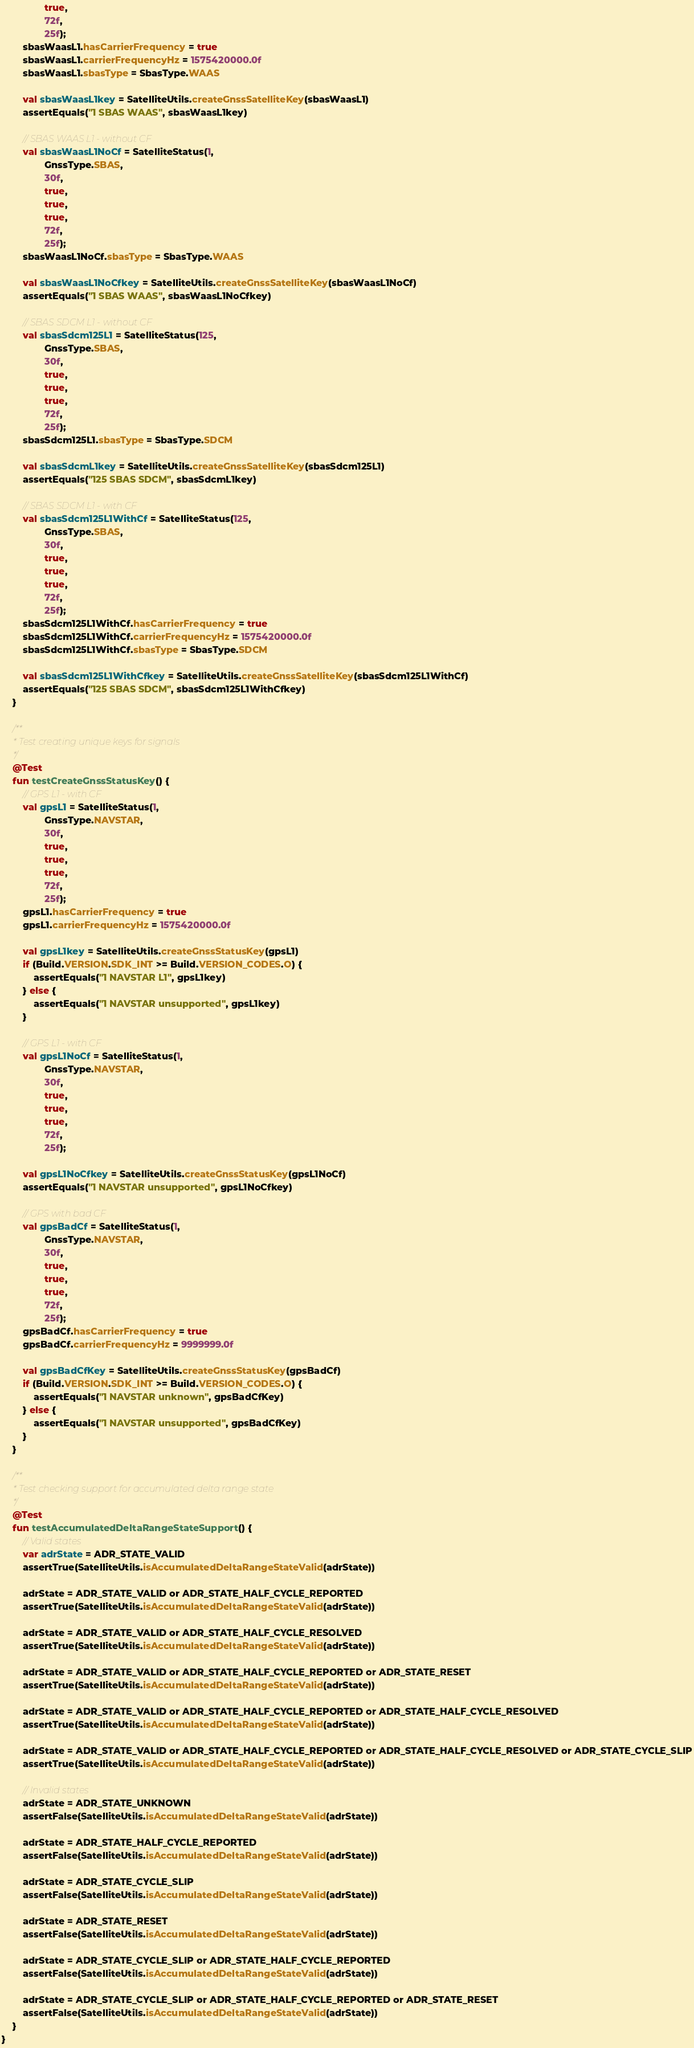<code> <loc_0><loc_0><loc_500><loc_500><_Kotlin_>                true,
                72f,
                25f);
        sbasWaasL1.hasCarrierFrequency = true
        sbasWaasL1.carrierFrequencyHz = 1575420000.0f
        sbasWaasL1.sbasType = SbasType.WAAS

        val sbasWaasL1key = SatelliteUtils.createGnssSatelliteKey(sbasWaasL1)
        assertEquals("1 SBAS WAAS", sbasWaasL1key)

        // SBAS WAAS L1 - without CF
        val sbasWaasL1NoCf = SatelliteStatus(1,
                GnssType.SBAS,
                30f,
                true,
                true,
                true,
                72f,
                25f);
        sbasWaasL1NoCf.sbasType = SbasType.WAAS

        val sbasWaasL1NoCfkey = SatelliteUtils.createGnssSatelliteKey(sbasWaasL1NoCf)
        assertEquals("1 SBAS WAAS", sbasWaasL1NoCfkey)

        // SBAS SDCM L1 - without CF
        val sbasSdcm125L1 = SatelliteStatus(125,
                GnssType.SBAS,
                30f,
                true,
                true,
                true,
                72f,
                25f);
        sbasSdcm125L1.sbasType = SbasType.SDCM

        val sbasSdcmL1key = SatelliteUtils.createGnssSatelliteKey(sbasSdcm125L1)
        assertEquals("125 SBAS SDCM", sbasSdcmL1key)

        // SBAS SDCM L1 - with CF
        val sbasSdcm125L1WithCf = SatelliteStatus(125,
                GnssType.SBAS,
                30f,
                true,
                true,
                true,
                72f,
                25f);
        sbasSdcm125L1WithCf.hasCarrierFrequency = true
        sbasSdcm125L1WithCf.carrierFrequencyHz = 1575420000.0f
        sbasSdcm125L1WithCf.sbasType = SbasType.SDCM

        val sbasSdcm125L1WithCfkey = SatelliteUtils.createGnssSatelliteKey(sbasSdcm125L1WithCf)
        assertEquals("125 SBAS SDCM", sbasSdcm125L1WithCfkey)
    }

    /**
     * Test creating unique keys for signals
     */
    @Test
    fun testCreateGnssStatusKey() {
        // GPS L1 - with CF
        val gpsL1 = SatelliteStatus(1,
                GnssType.NAVSTAR,
                30f,
                true,
                true,
                true,
                72f,
                25f);
        gpsL1.hasCarrierFrequency = true
        gpsL1.carrierFrequencyHz = 1575420000.0f

        val gpsL1key = SatelliteUtils.createGnssStatusKey(gpsL1)
        if (Build.VERSION.SDK_INT >= Build.VERSION_CODES.O) {
            assertEquals("1 NAVSTAR L1", gpsL1key)
        } else {
            assertEquals("1 NAVSTAR unsupported", gpsL1key)
        }

        // GPS L1 - with CF
        val gpsL1NoCf = SatelliteStatus(1,
                GnssType.NAVSTAR,
                30f,
                true,
                true,
                true,
                72f,
                25f);

        val gpsL1NoCfkey = SatelliteUtils.createGnssStatusKey(gpsL1NoCf)
        assertEquals("1 NAVSTAR unsupported", gpsL1NoCfkey)

        // GPS with bad CF
        val gpsBadCf = SatelliteStatus(1,
                GnssType.NAVSTAR,
                30f,
                true,
                true,
                true,
                72f,
                25f);
        gpsBadCf.hasCarrierFrequency = true
        gpsBadCf.carrierFrequencyHz = 9999999.0f

        val gpsBadCfKey = SatelliteUtils.createGnssStatusKey(gpsBadCf)
        if (Build.VERSION.SDK_INT >= Build.VERSION_CODES.O) {
            assertEquals("1 NAVSTAR unknown", gpsBadCfKey)
        } else {
            assertEquals("1 NAVSTAR unsupported", gpsBadCfKey)
        }
    }

    /**
     * Test checking support for accumulated delta range state
     */
    @Test
    fun testAccumulatedDeltaRangeStateSupport() {
        // Valid states
        var adrState = ADR_STATE_VALID
        assertTrue(SatelliteUtils.isAccumulatedDeltaRangeStateValid(adrState))

        adrState = ADR_STATE_VALID or ADR_STATE_HALF_CYCLE_REPORTED
        assertTrue(SatelliteUtils.isAccumulatedDeltaRangeStateValid(adrState))

        adrState = ADR_STATE_VALID or ADR_STATE_HALF_CYCLE_RESOLVED
        assertTrue(SatelliteUtils.isAccumulatedDeltaRangeStateValid(adrState))

        adrState = ADR_STATE_VALID or ADR_STATE_HALF_CYCLE_REPORTED or ADR_STATE_RESET
        assertTrue(SatelliteUtils.isAccumulatedDeltaRangeStateValid(adrState))

        adrState = ADR_STATE_VALID or ADR_STATE_HALF_CYCLE_REPORTED or ADR_STATE_HALF_CYCLE_RESOLVED
        assertTrue(SatelliteUtils.isAccumulatedDeltaRangeStateValid(adrState))

        adrState = ADR_STATE_VALID or ADR_STATE_HALF_CYCLE_REPORTED or ADR_STATE_HALF_CYCLE_RESOLVED or ADR_STATE_CYCLE_SLIP
        assertTrue(SatelliteUtils.isAccumulatedDeltaRangeStateValid(adrState))

        // Invalid states
        adrState = ADR_STATE_UNKNOWN
        assertFalse(SatelliteUtils.isAccumulatedDeltaRangeStateValid(adrState))

        adrState = ADR_STATE_HALF_CYCLE_REPORTED
        assertFalse(SatelliteUtils.isAccumulatedDeltaRangeStateValid(adrState))

        adrState = ADR_STATE_CYCLE_SLIP
        assertFalse(SatelliteUtils.isAccumulatedDeltaRangeStateValid(adrState))

        adrState = ADR_STATE_RESET
        assertFalse(SatelliteUtils.isAccumulatedDeltaRangeStateValid(adrState))

        adrState = ADR_STATE_CYCLE_SLIP or ADR_STATE_HALF_CYCLE_REPORTED
        assertFalse(SatelliteUtils.isAccumulatedDeltaRangeStateValid(adrState))

        adrState = ADR_STATE_CYCLE_SLIP or ADR_STATE_HALF_CYCLE_REPORTED or ADR_STATE_RESET
        assertFalse(SatelliteUtils.isAccumulatedDeltaRangeStateValid(adrState))
    }
}</code> 